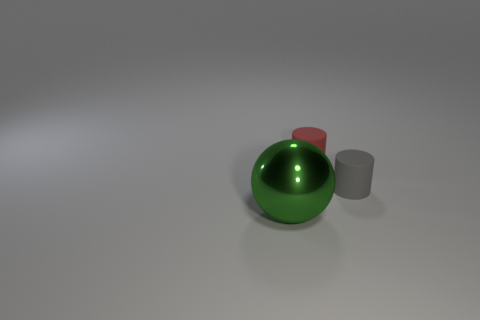What number of objects are small red cylinders or objects behind the tiny gray matte thing?
Make the answer very short. 1. There is a tiny matte object to the left of the tiny gray rubber cylinder; is its shape the same as the gray thing?
Provide a succinct answer. Yes. How many balls are right of the rubber object that is behind the cylinder on the right side of the red thing?
Make the answer very short. 0. Are there any other things that are the same shape as the tiny gray matte object?
Keep it short and to the point. Yes. How many things are either large gray metal balls or small matte cylinders?
Your answer should be very brief. 2. Do the large green shiny thing and the small thing that is behind the tiny gray thing have the same shape?
Provide a short and direct response. No. Are there an equal number of big blue rubber cubes and gray matte objects?
Make the answer very short. No. What shape is the green thing to the left of the red rubber object?
Your answer should be compact. Sphere. Is the big object the same shape as the red rubber object?
Keep it short and to the point. No. What is the size of the other object that is the same shape as the tiny gray rubber thing?
Ensure brevity in your answer.  Small. 